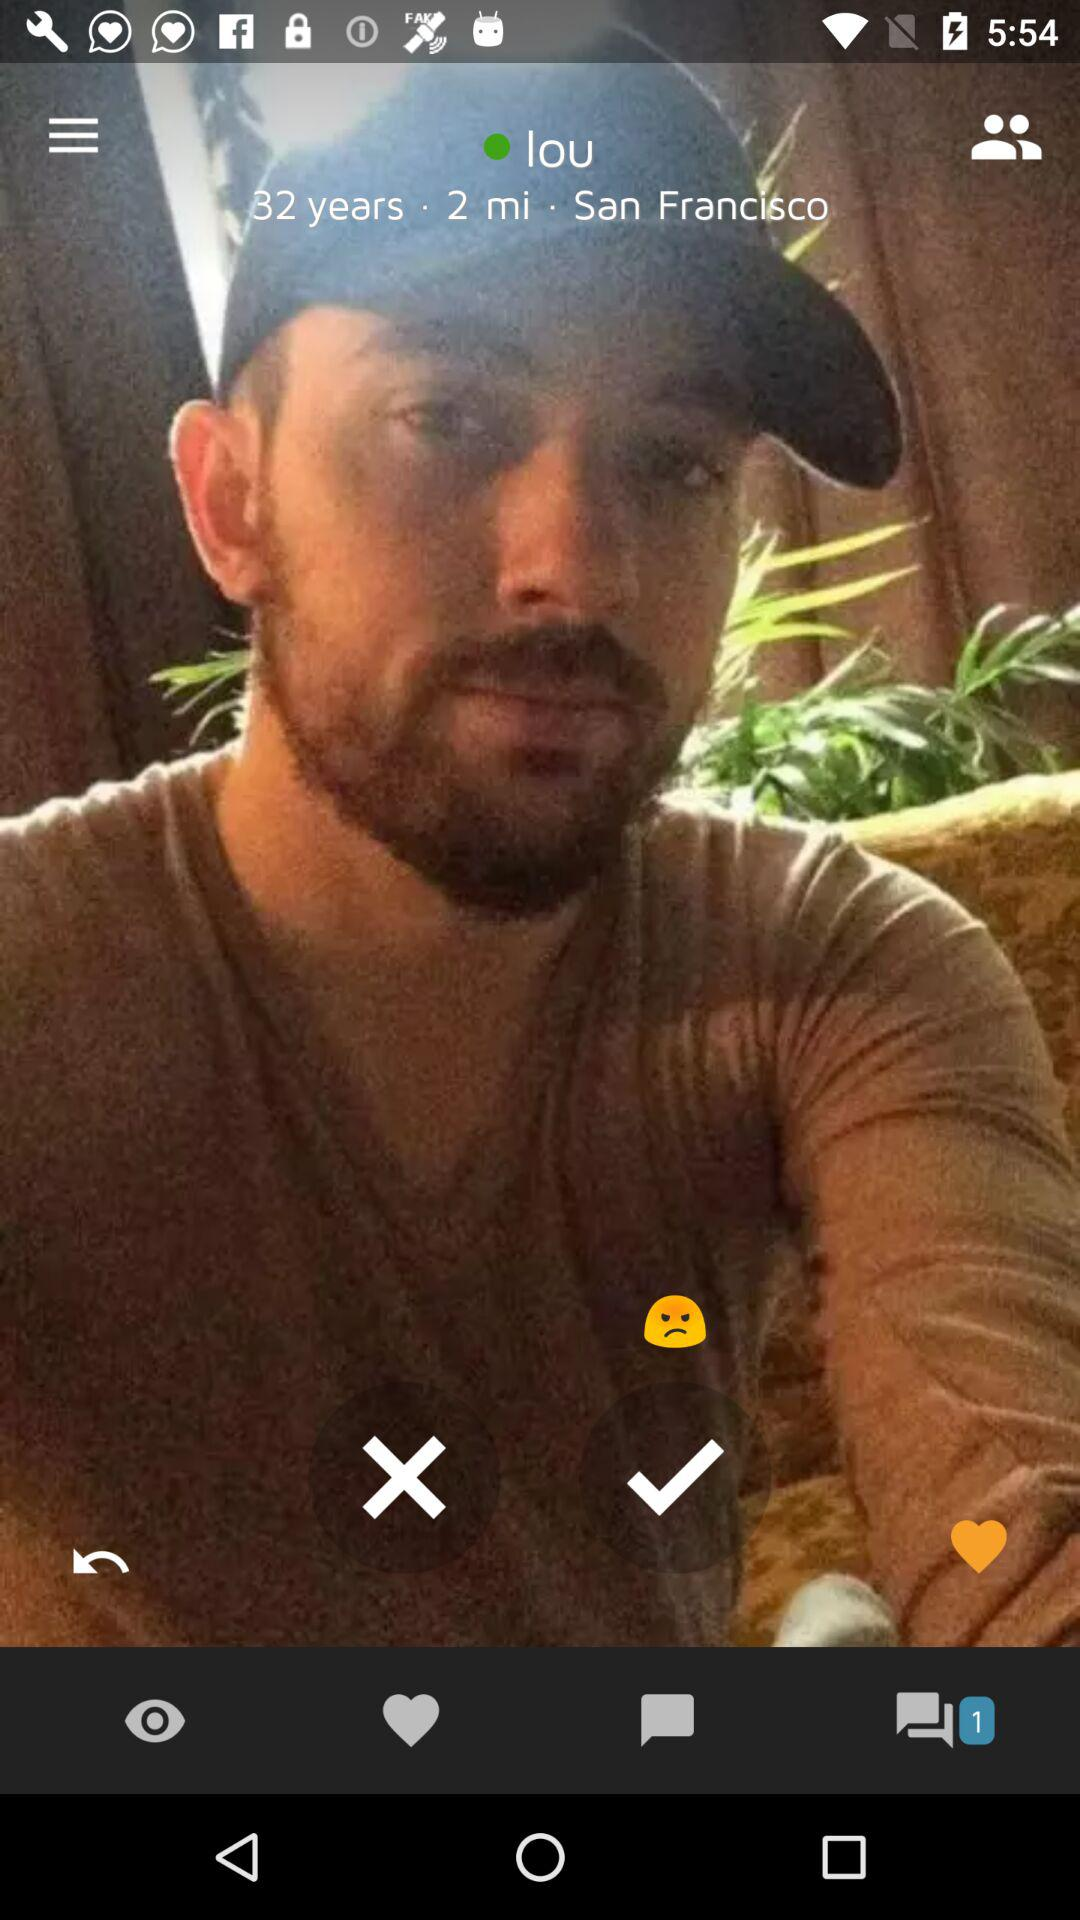What is the age of Lou? The age is 32 years. 